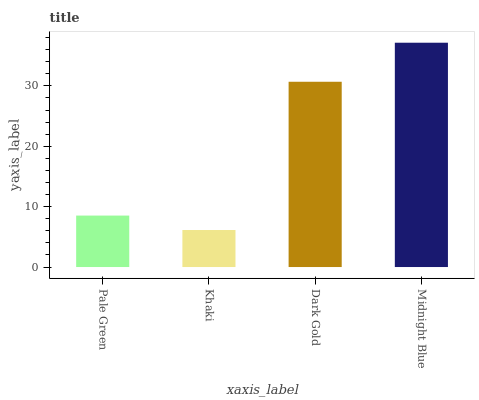Is Khaki the minimum?
Answer yes or no. Yes. Is Midnight Blue the maximum?
Answer yes or no. Yes. Is Dark Gold the minimum?
Answer yes or no. No. Is Dark Gold the maximum?
Answer yes or no. No. Is Dark Gold greater than Khaki?
Answer yes or no. Yes. Is Khaki less than Dark Gold?
Answer yes or no. Yes. Is Khaki greater than Dark Gold?
Answer yes or no. No. Is Dark Gold less than Khaki?
Answer yes or no. No. Is Dark Gold the high median?
Answer yes or no. Yes. Is Pale Green the low median?
Answer yes or no. Yes. Is Khaki the high median?
Answer yes or no. No. Is Dark Gold the low median?
Answer yes or no. No. 